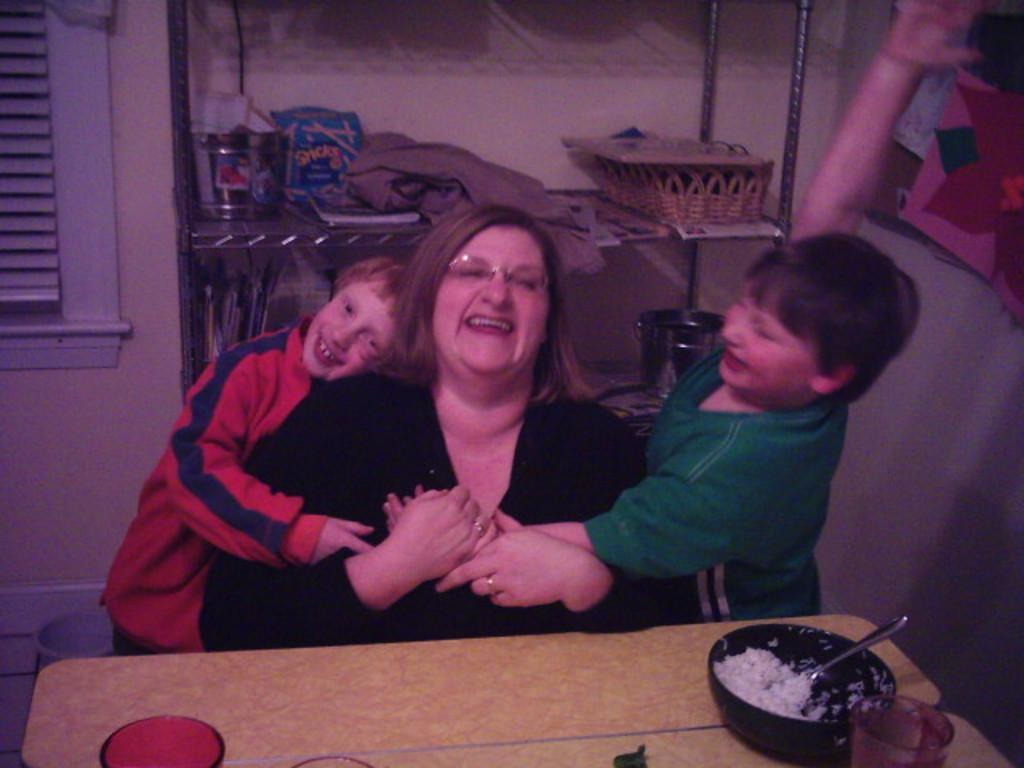Can you describe this image briefly? There are three persons in this image two kids playing with a woman and there is a rice bowl at the right side of the image and at the background of the image there are objects. 